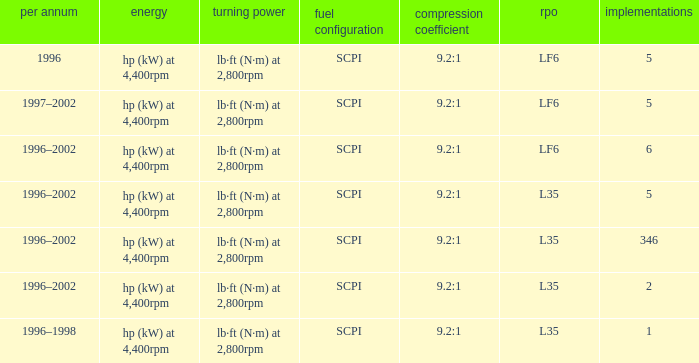What are the torque characteristics of the model made in 1996? Lb·ft (n·m) at 2,800rpm. Could you parse the entire table? {'header': ['per annum', 'energy', 'turning power', 'fuel configuration', 'compression coefficient', 'rpo', 'implementations'], 'rows': [['1996', 'hp (kW) at 4,400rpm', 'lb·ft (N·m) at 2,800rpm', 'SCPI', '9.2:1', 'LF6', '5'], ['1997–2002', 'hp (kW) at 4,400rpm', 'lb·ft (N·m) at 2,800rpm', 'SCPI', '9.2:1', 'LF6', '5'], ['1996–2002', 'hp (kW) at 4,400rpm', 'lb·ft (N·m) at 2,800rpm', 'SCPI', '9.2:1', 'LF6', '6'], ['1996–2002', 'hp (kW) at 4,400rpm', 'lb·ft (N·m) at 2,800rpm', 'SCPI', '9.2:1', 'L35', '5'], ['1996–2002', 'hp (kW) at 4,400rpm', 'lb·ft (N·m) at 2,800rpm', 'SCPI', '9.2:1', 'L35', '346'], ['1996–2002', 'hp (kW) at 4,400rpm', 'lb·ft (N·m) at 2,800rpm', 'SCPI', '9.2:1', 'L35', '2'], ['1996–1998', 'hp (kW) at 4,400rpm', 'lb·ft (N·m) at 2,800rpm', 'SCPI', '9.2:1', 'L35', '1']]} 